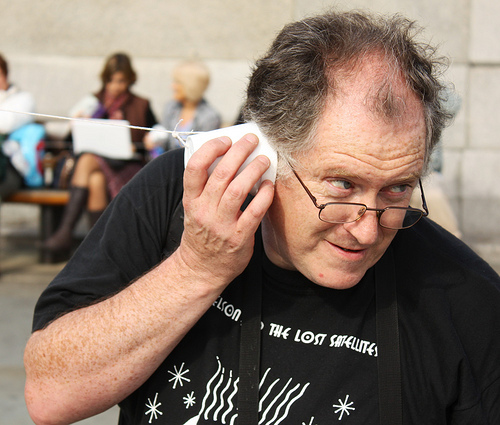<image>
Is the woman behind the man? Yes. From this viewpoint, the woman is positioned behind the man, with the man partially or fully occluding the woman. 